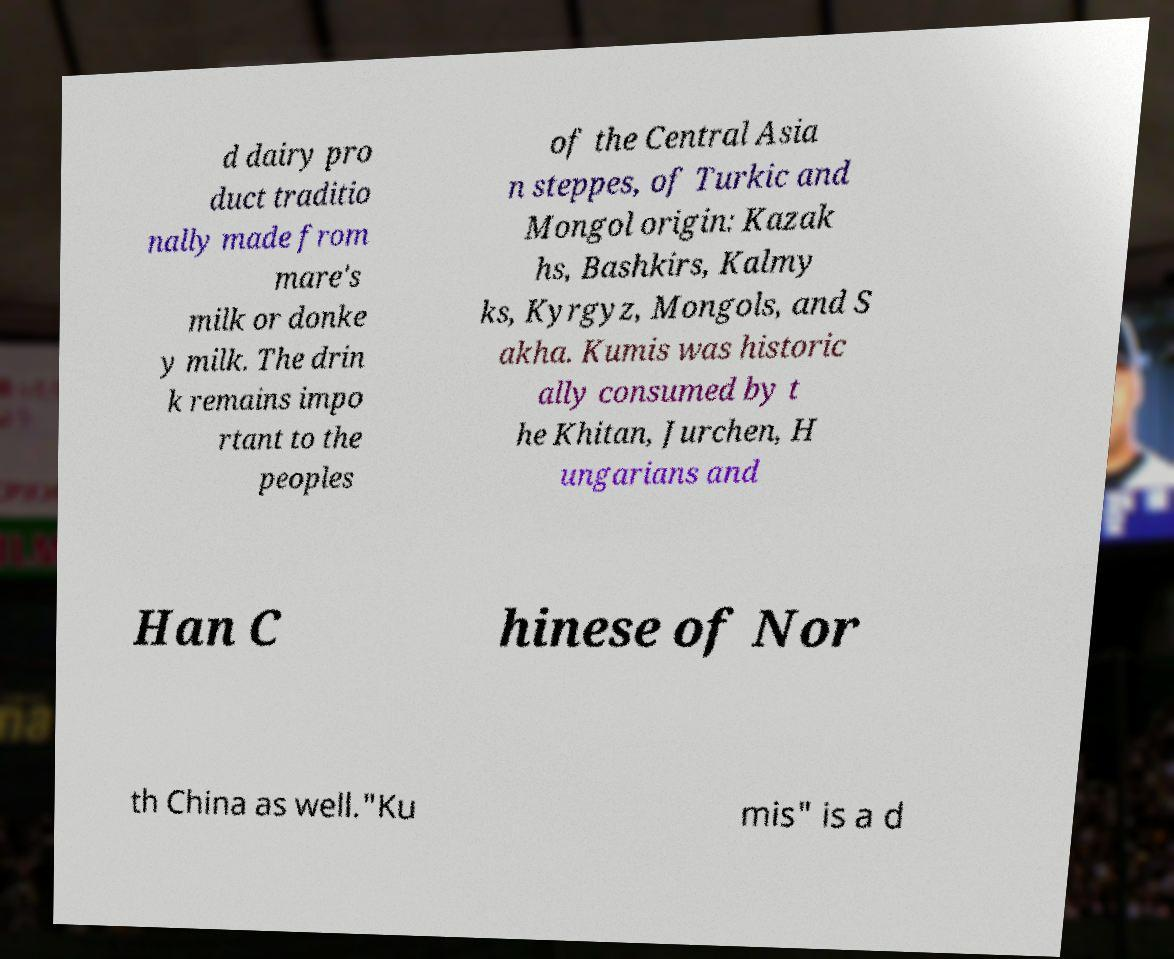Please read and relay the text visible in this image. What does it say? d dairy pro duct traditio nally made from mare's milk or donke y milk. The drin k remains impo rtant to the peoples of the Central Asia n steppes, of Turkic and Mongol origin: Kazak hs, Bashkirs, Kalmy ks, Kyrgyz, Mongols, and S akha. Kumis was historic ally consumed by t he Khitan, Jurchen, H ungarians and Han C hinese of Nor th China as well."Ku mis" is a d 